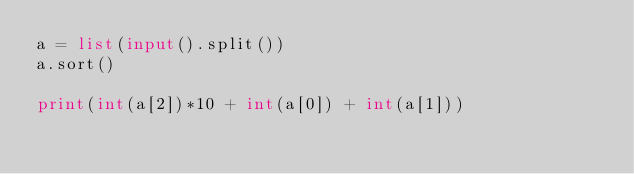Convert code to text. <code><loc_0><loc_0><loc_500><loc_500><_Python_>a = list(input().split())
a.sort()

print(int(a[2])*10 + int(a[0]) + int(a[1]))</code> 